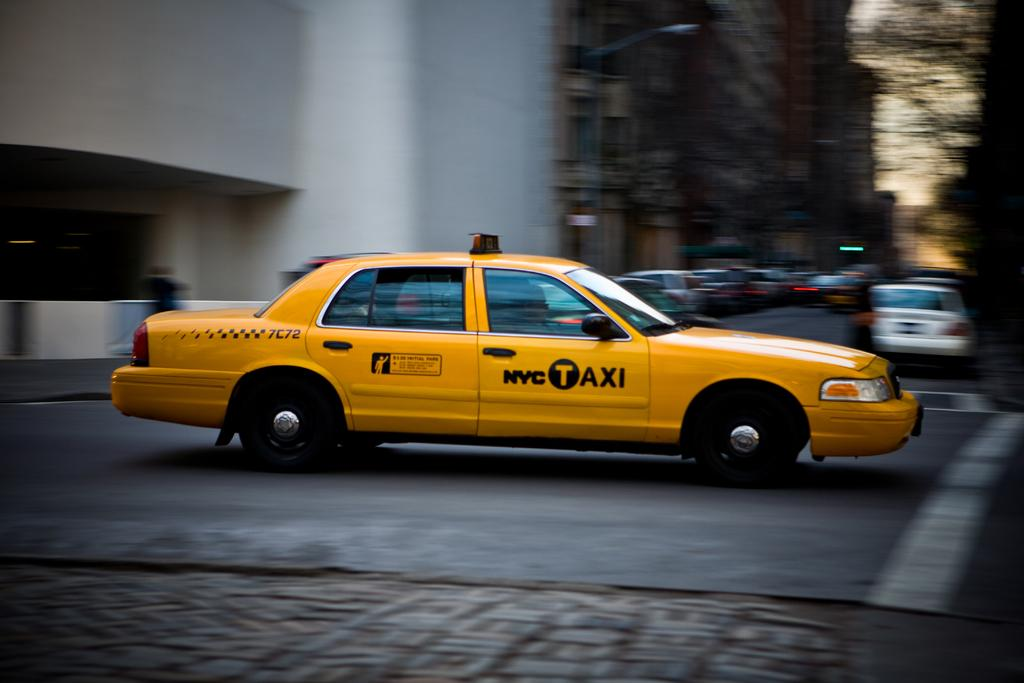<image>
Summarize the visual content of the image. A bright yellow NYC Taxi speeds through an intersection. 